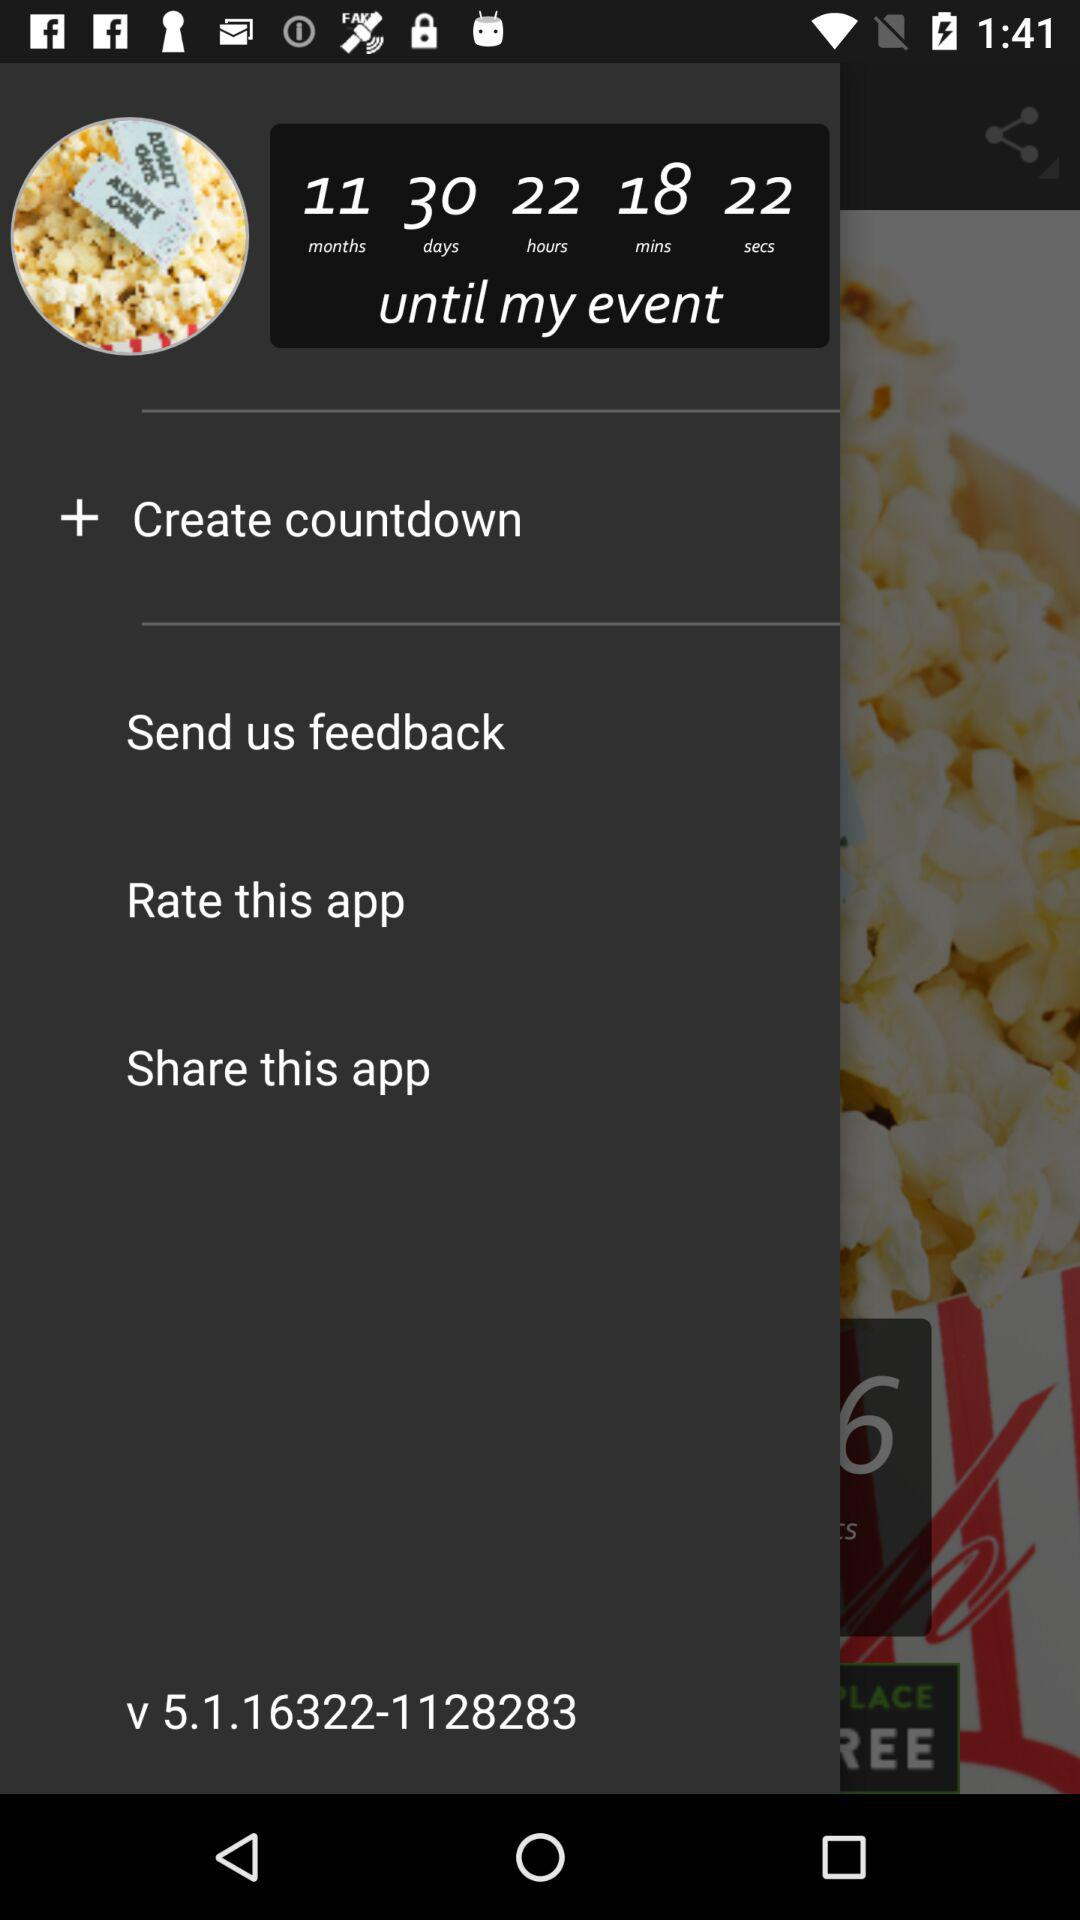How much time is left for the event? The left time is 11 months 30 days 22 hours 18 minutes 22 seconds. 